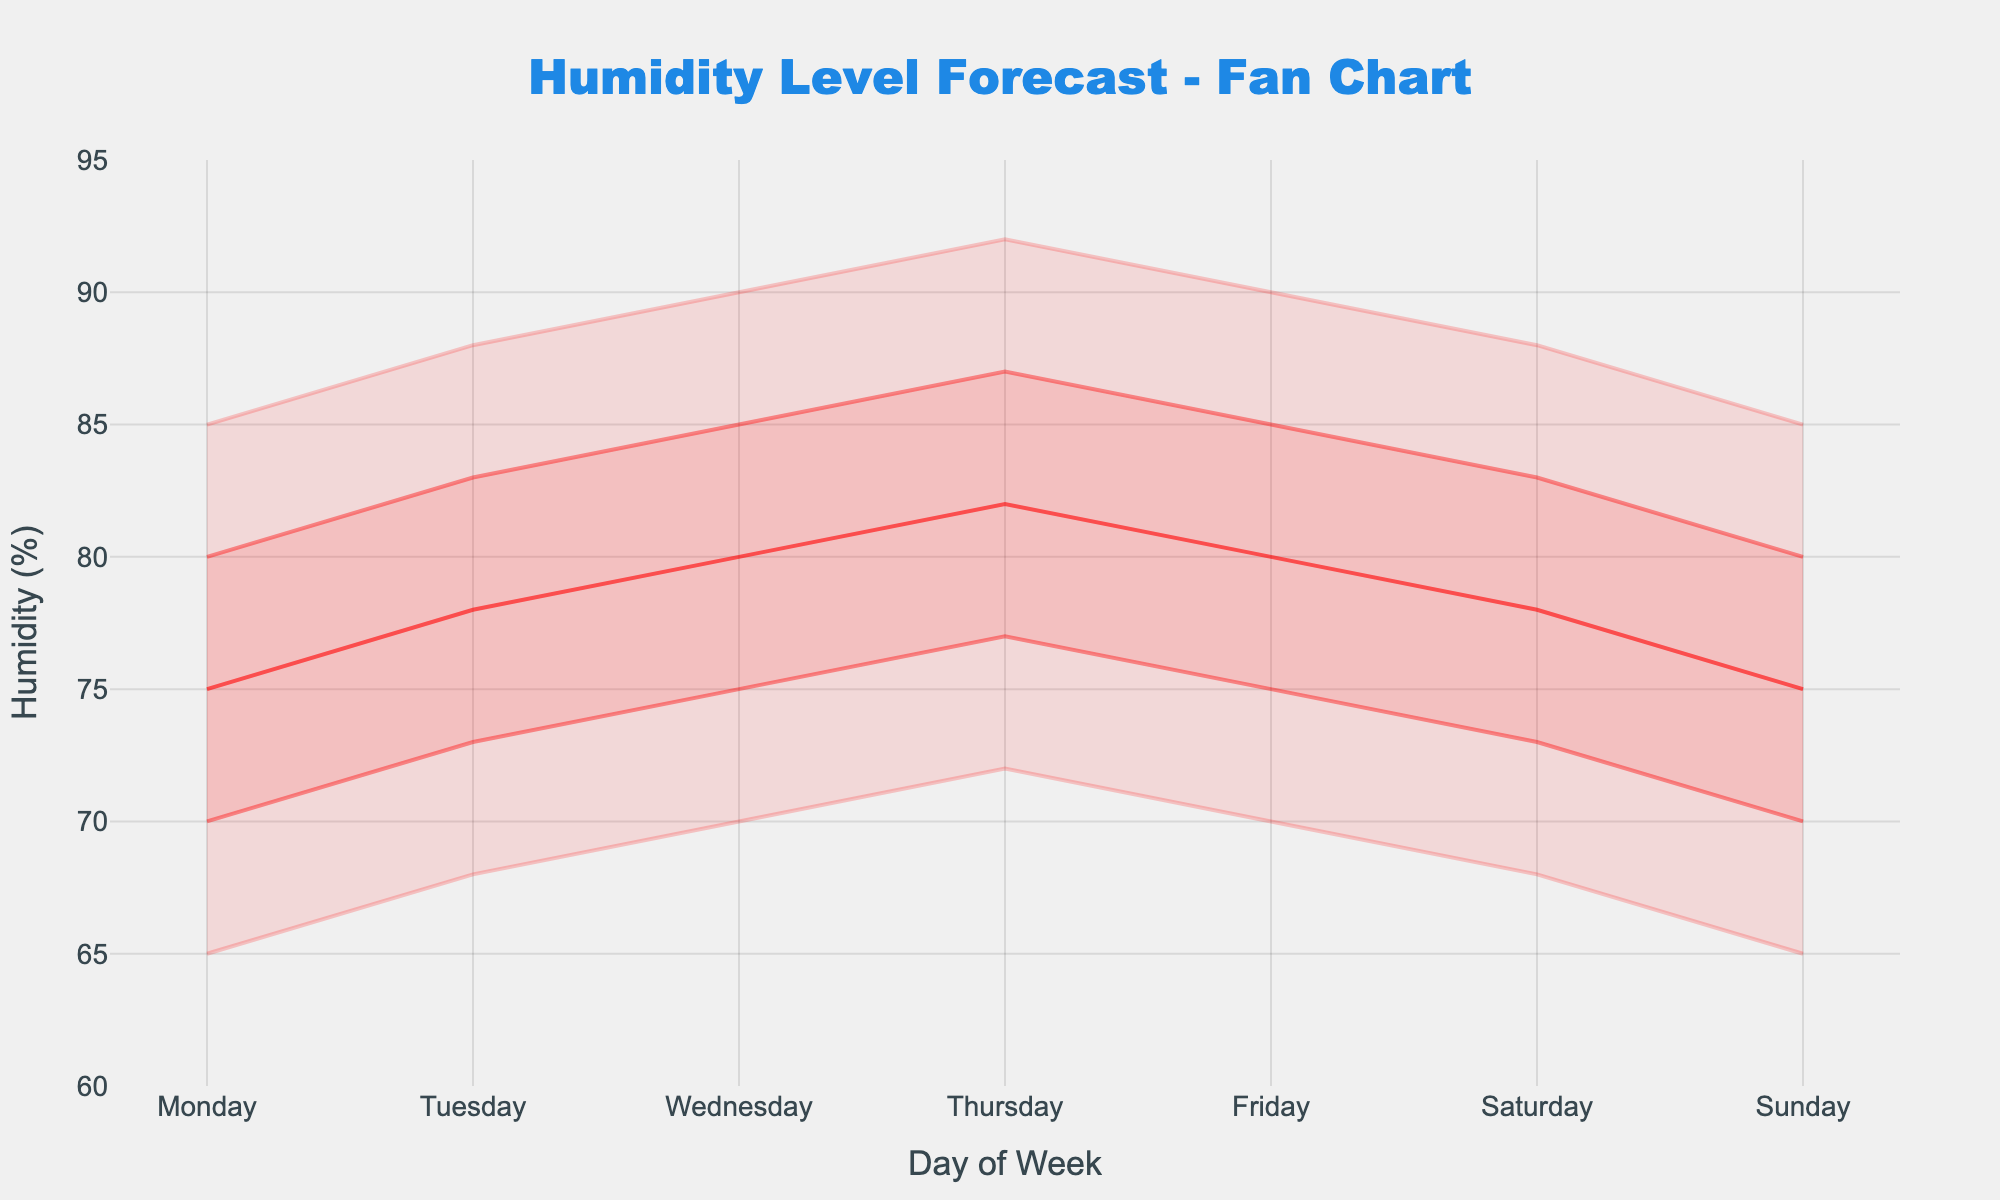What is the title of the figure? The title of the figure is displayed at the top center in large, bold text. It reads "Humidity Level Forecast - Fan Chart".
Answer: Humidity Level Forecast - Fan Chart What is the humidity range covered in the entire forecast? The humidity range in the forecast spans from the minimum low value to the maximum high value across all days. Looking at the lowest low (Monday and Sunday) and the highest high (Thursday), the range is from 65% to 92%.
Answer: 65% to 92% On which day is the median humidity forecast the lowest? To determine the lowest median forecast, look at the median values for each day. The lowest median value is 75%, which occurs on Monday and Sunday.
Answer: Monday and Sunday How does the range between Q1 and Q3 on Wednesday compare to the range on Friday? To compare the range between Q1 and Q3, subtract Q1 from Q3 for each day. For Wednesday, Q3 (85%) - Q1 (75%) = 10%. For Friday, Q3 (85%) - Q1 (75%) = 10%. Comparatively, the ranges are equal on both days.
Answer: Equal Which day has the widest spread of possible humidity levels (from low to high)? Calculate the spread by subtracting the low value from the high value for each day. The day with the highest result has the widest spread. Thursday has the maximum spread: 92% - 72% = 20%.
Answer: Thursday What is the highest median humidity forecast in the week, and on which day(s) does it occur? Look at the median values each day and find the highest one. The highest median value is 82%, which occurs on Thursday.
Answer: 82%, Thursday What is the difference between the highest high and the low of Saturday? Identify the highest high value (92% on Thursday) and the low value of Saturday (68%). Subtract the low from the highest high: 92% - 68% = 24%.
Answer: 24% How does Sunday’s median humidity forecast compare to Tuesday’s? Compare the median values directly for Sunday (75%) and Tuesday (78%). Sunday's median is lower than Tuesday's.
Answer: Lower On which days is the Q3 humidity level above the median humidity level of Tuesday? Tuesday's median is 78%. Identify the days where Q3 is higher than 78%. These days are Tuesday, Wednesday, Thursday, and Friday.
Answer: Tuesday, Wednesday, Thursday, Friday What is the average of the median humidity levels over the week? Add the median values for all days and divide by the number of days: (75 + 78 + 80 + 82 + 80 + 78 + 75) / 7 = 78.
Answer: 78 